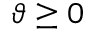<formula> <loc_0><loc_0><loc_500><loc_500>\vartheta \geq 0</formula> 